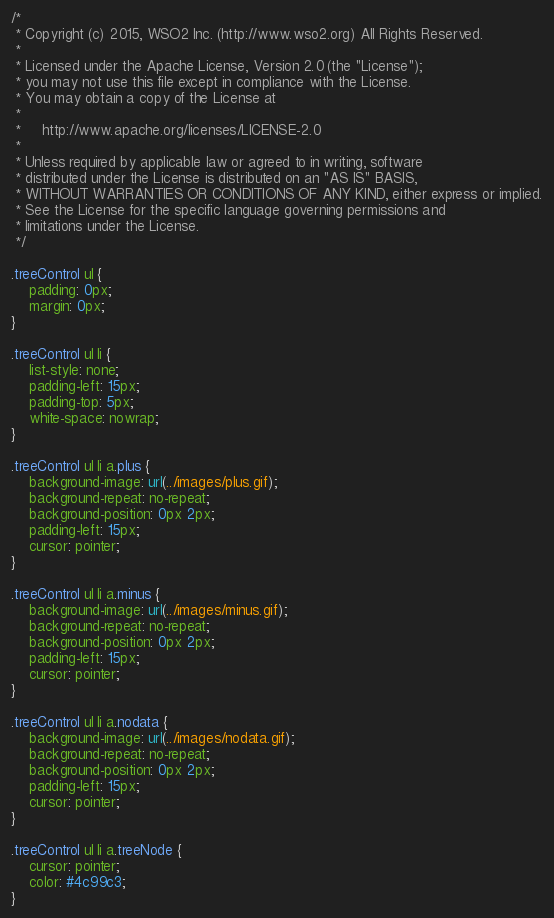<code> <loc_0><loc_0><loc_500><loc_500><_CSS_>/*
 * Copyright (c) 2015, WSO2 Inc. (http://www.wso2.org) All Rights Reserved.
 *
 * Licensed under the Apache License, Version 2.0 (the "License");
 * you may not use this file except in compliance with the License.
 * You may obtain a copy of the License at
 *
 *     http://www.apache.org/licenses/LICENSE-2.0
 *
 * Unless required by applicable law or agreed to in writing, software
 * distributed under the License is distributed on an "AS IS" BASIS,
 * WITHOUT WARRANTIES OR CONDITIONS OF ANY KIND, either express or implied.
 * See the License for the specific language governing permissions and
 * limitations under the License.
 */

.treeControl ul {
    padding: 0px;
    margin: 0px;
}

.treeControl ul li {
    list-style: none;
    padding-left: 15px;
    padding-top: 5px;
    white-space: nowrap;
}

.treeControl ul li a.plus {
    background-image: url(../images/plus.gif);
    background-repeat: no-repeat;
    background-position: 0px 2px;
    padding-left: 15px;
    cursor: pointer;
}

.treeControl ul li a.minus {
    background-image: url(../images/minus.gif);
    background-repeat: no-repeat;
    background-position: 0px 2px;
    padding-left: 15px;
    cursor: pointer;
}

.treeControl ul li a.nodata {
    background-image: url(../images/nodata.gif);
    background-repeat: no-repeat;
    background-position: 0px 2px;
    padding-left: 15px;
    cursor: pointer;
}

.treeControl ul li a.treeNode {
    cursor: pointer;
    color: #4c99c3;
}</code> 